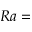<formula> <loc_0><loc_0><loc_500><loc_500>R a =</formula> 